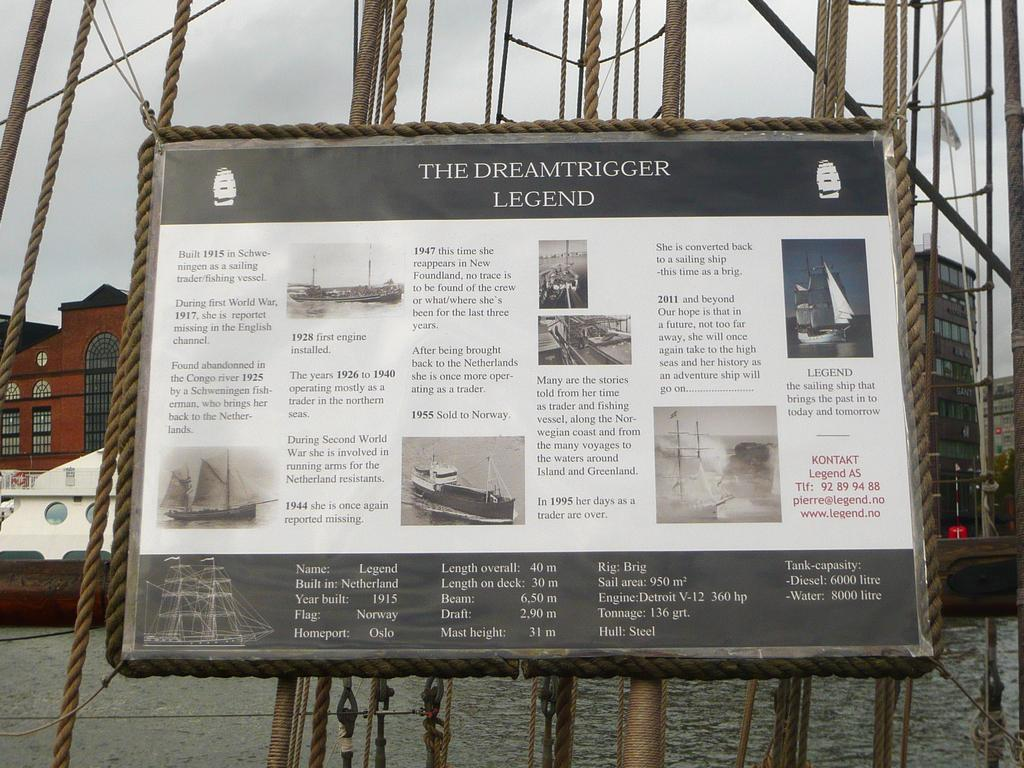What is the main object in the image that is attached to ropes? There is a board attached to ropes in the image. What is the boat's position in relation to the water in the image? The boat is above the water in the image. What can be seen in the distance behind the boat and board? Buildings and the sky are visible in the background of the image. Where is the map that the father is holding in the image? There is no map or father present in the image. What type of paste is being used to stick the board to the ropes in the image? There is no paste mentioned or visible in the image; the board is simply attached to the ropes. 